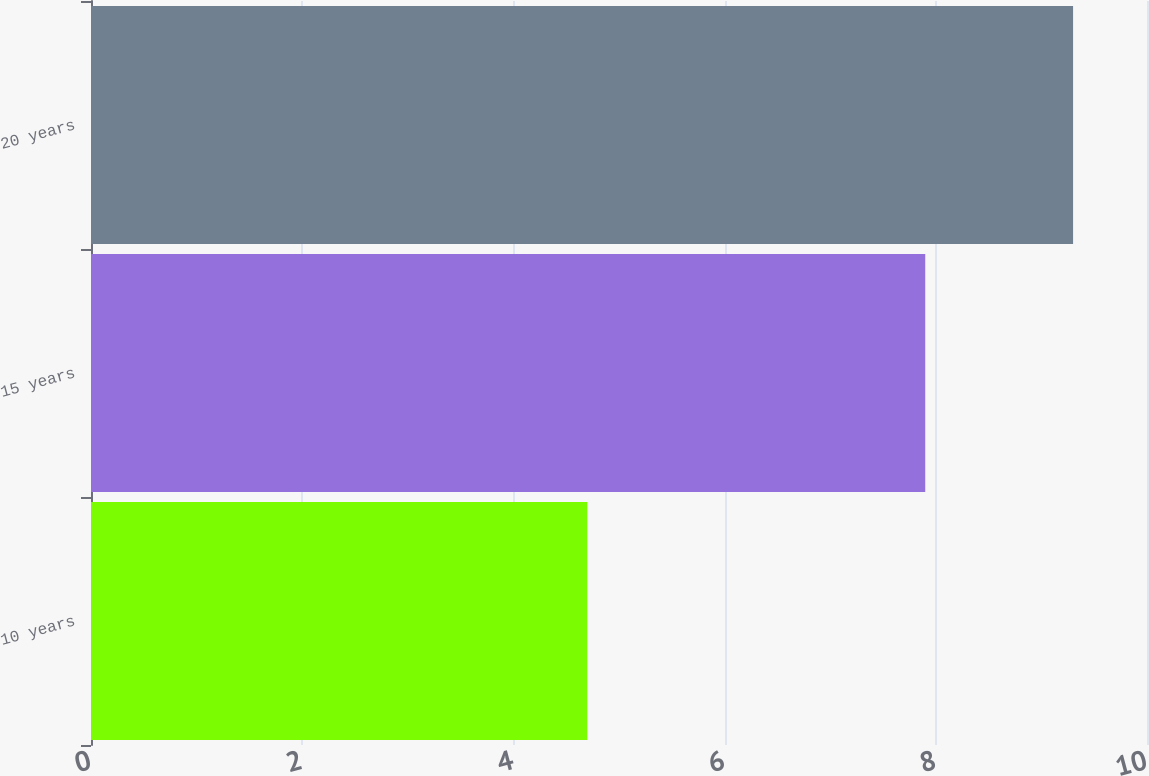Convert chart to OTSL. <chart><loc_0><loc_0><loc_500><loc_500><bar_chart><fcel>10 years<fcel>15 years<fcel>20 years<nl><fcel>4.7<fcel>7.9<fcel>9.3<nl></chart> 